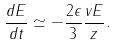Convert formula to latex. <formula><loc_0><loc_0><loc_500><loc_500>\frac { d E } { d t } \simeq - \frac { 2 \epsilon } { 3 } \frac { v E } { z } .</formula> 